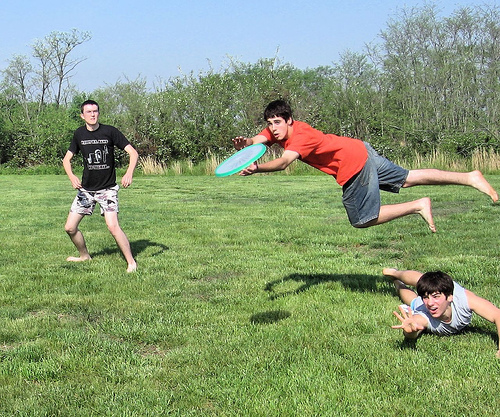Please provide a short description for this region: [0.12, 0.33, 0.26, 0.47]. A boy in a black t-shirt. 